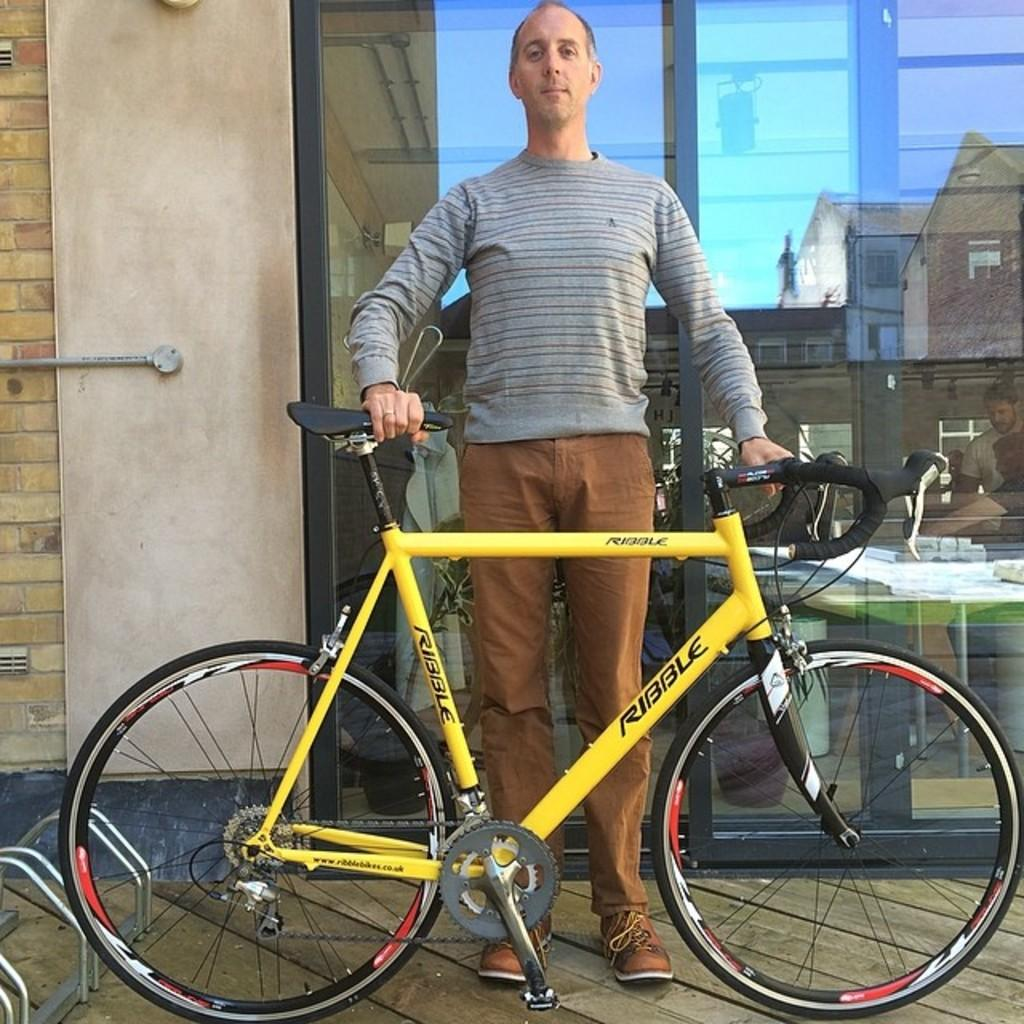Who is present in the image? There is a man in the image. What is the man holding in the image? The man is holding a yellow bicycle. What can be seen in the background of the image? There is a glass door and a wall in the background of the image. What type of cork can be seen on the wall in the image? There is no cork visible on the wall in the image. Is there a train passing by in the image? There is no train present in the image. 